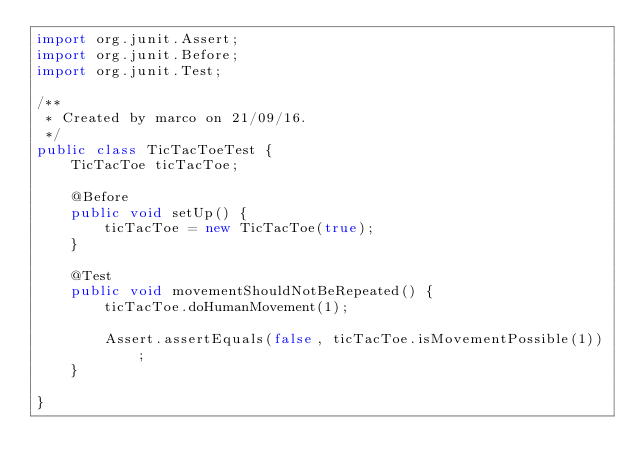Convert code to text. <code><loc_0><loc_0><loc_500><loc_500><_Java_>import org.junit.Assert;
import org.junit.Before;
import org.junit.Test;

/**
 * Created by marco on 21/09/16.
 */
public class TicTacToeTest {
    TicTacToe ticTacToe;

    @Before
    public void setUp() {
        ticTacToe = new TicTacToe(true);
    }

    @Test
    public void movementShouldNotBeRepeated() {
        ticTacToe.doHumanMovement(1);

        Assert.assertEquals(false, ticTacToe.isMovementPossible(1));
    }

}
</code> 